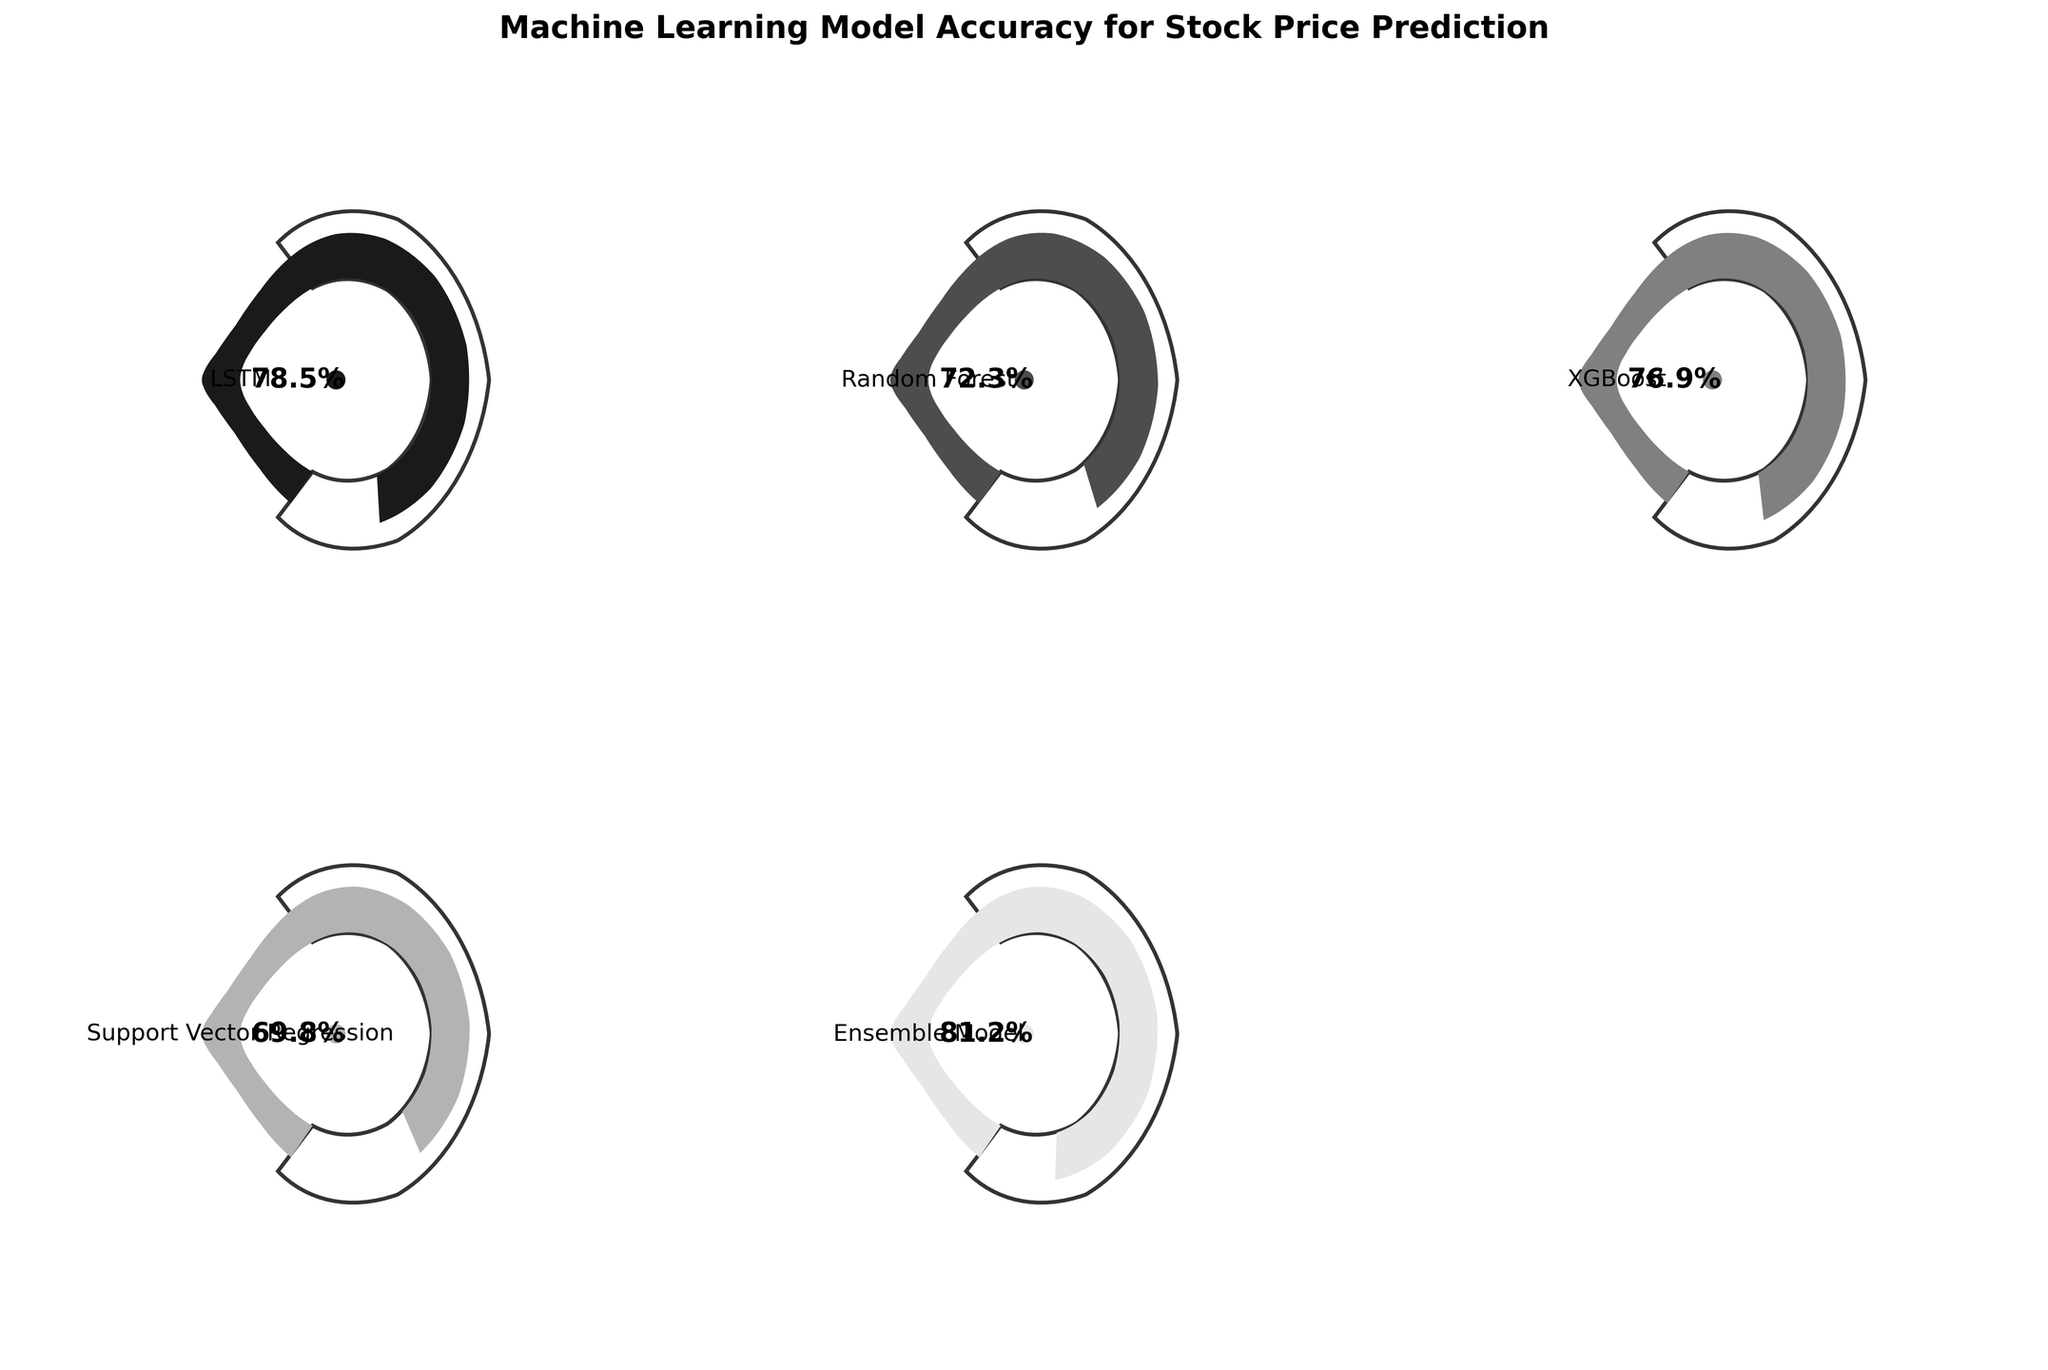Which model has the highest accuracy? The Ensemble Model gauge shows the highest accuracy at 81.2% based on the visual indicator.
Answer: Ensemble Model What is the title of the figure? The title at the top of the figure reads "Machine Learning Model Accuracy for Stock Price Prediction".
Answer: Machine Learning Model Accuracy for Stock Price Prediction How many models are being compared in the figure? There are five gauges visible in the figure, each representing a different model. Counting these gives the number of models being compared as five.
Answer: Five Which model has the lowest accuracy? The Support Vector Regression (SVR) gauge shows the lowest accuracy at 69.8%, according to the indicator.
Answer: Support Vector Regression What is the difference in accuracy between the LSTM and Random Forest models? The LSTM model has an accuracy of 78.5% and the Random Forest model has 72.3%. Subtracting these two values, 78.5 - 72.3 = 6.2%.
Answer: 6.2% What is the combined accuracy of the Random Forest and XGBoost models? The Random Forest model's accuracy is 72.3% and XGBoost's accuracy is 76.9%. Adding these gives 72.3 + 76.9 = 149.2%.
Answer: 149.2% Which models have accuracy greater than 75%? The gauges indicate that the LSTM model (78.5%), XGBoost model (76.9%), and Ensemble Model (81.2%) all have accuracies greater than 75%.
Answer: LSTM, XGBoost, Ensemble Model What color is the gauge indicator for the model with the second-highest accuracy? The second-highest accuracy model is the LSTM at 78.5%. The color of its gauge indicator is the second from the brightest shade among the five colors, which is a dark gray.
Answer: Dark gray Is the accuracy of the Ensemble Model more than 80%? The gauge for the Ensemble Model shows an accuracy of 81.2%, which is greater than 80%.
Answer: Yes 